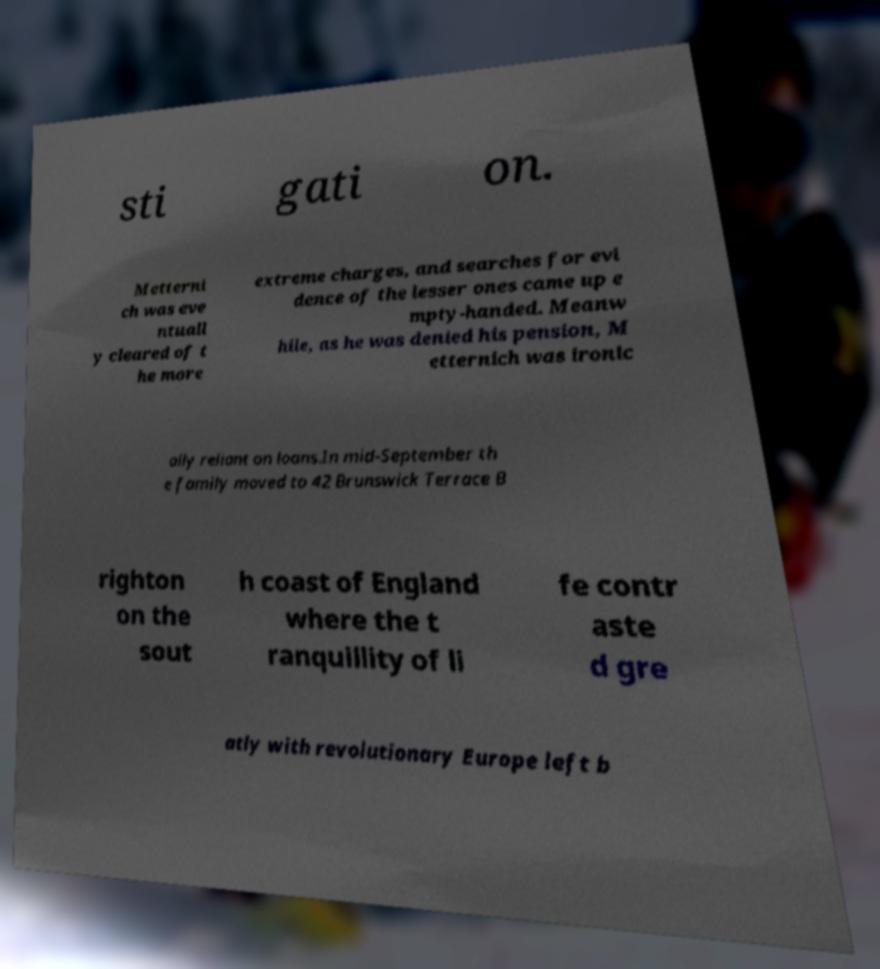Please read and relay the text visible in this image. What does it say? sti gati on. Metterni ch was eve ntuall y cleared of t he more extreme charges, and searches for evi dence of the lesser ones came up e mpty-handed. Meanw hile, as he was denied his pension, M etternich was ironic ally reliant on loans.In mid-September th e family moved to 42 Brunswick Terrace B righton on the sout h coast of England where the t ranquillity of li fe contr aste d gre atly with revolutionary Europe left b 